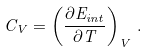<formula> <loc_0><loc_0><loc_500><loc_500>C _ { V } = \left ( \frac { \partial E _ { i n t } } { \partial T } \right ) _ { V } \, .</formula> 